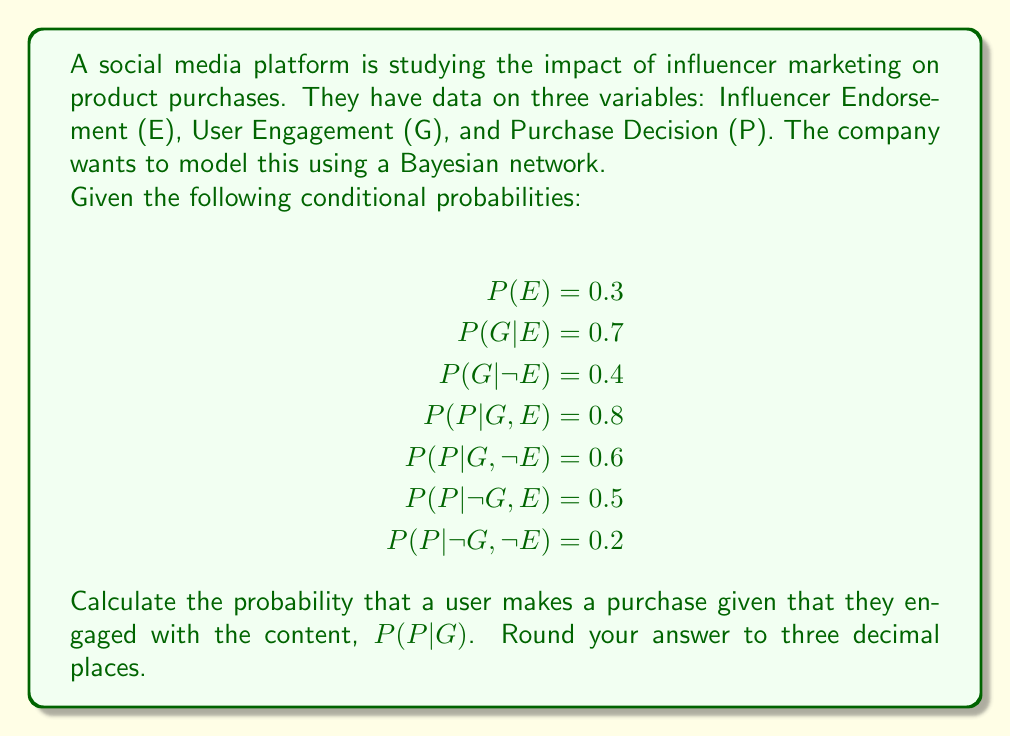Provide a solution to this math problem. To solve this problem, we'll use Bayes' theorem and the law of total probability. Let's break it down step by step:

1) We want to calculate $P(P|G)$. Using Bayes' theorem, we can write:

   $$P(P|G) = \frac{P(G|P)P(P)}{P(G)}$$

2) We don't have $P(G|P)$ or $P(P)$ directly, so we need to calculate $P(G,P)$ and $P(G)$ using the law of total probability.

3) First, let's calculate $P(G)$:

   $$P(G) = P(G|E)P(E) + P(G|\neg E)P(\neg E)$$
   $$P(G) = 0.7 \cdot 0.3 + 0.4 \cdot 0.7 = 0.21 + 0.28 = 0.49$$

4) Now, let's calculate $P(G,P)$:

   $$P(G,P) = P(P|G,E)P(G|E)P(E) + P(P|G,\neg E)P(G|\neg E)P(\neg E)$$
   $$P(G,P) = 0.8 \cdot 0.7 \cdot 0.3 + 0.6 \cdot 0.4 \cdot 0.7$$
   $$P(G,P) = 0.168 + 0.168 = 0.336$$

5) Now we have all the components to calculate $P(P|G)$:

   $$P(P|G) = \frac{P(G,P)}{P(G)} = \frac{0.336}{0.49} \approx 0.6857$$

6) Rounding to three decimal places, we get 0.686.
Answer: 0.686 